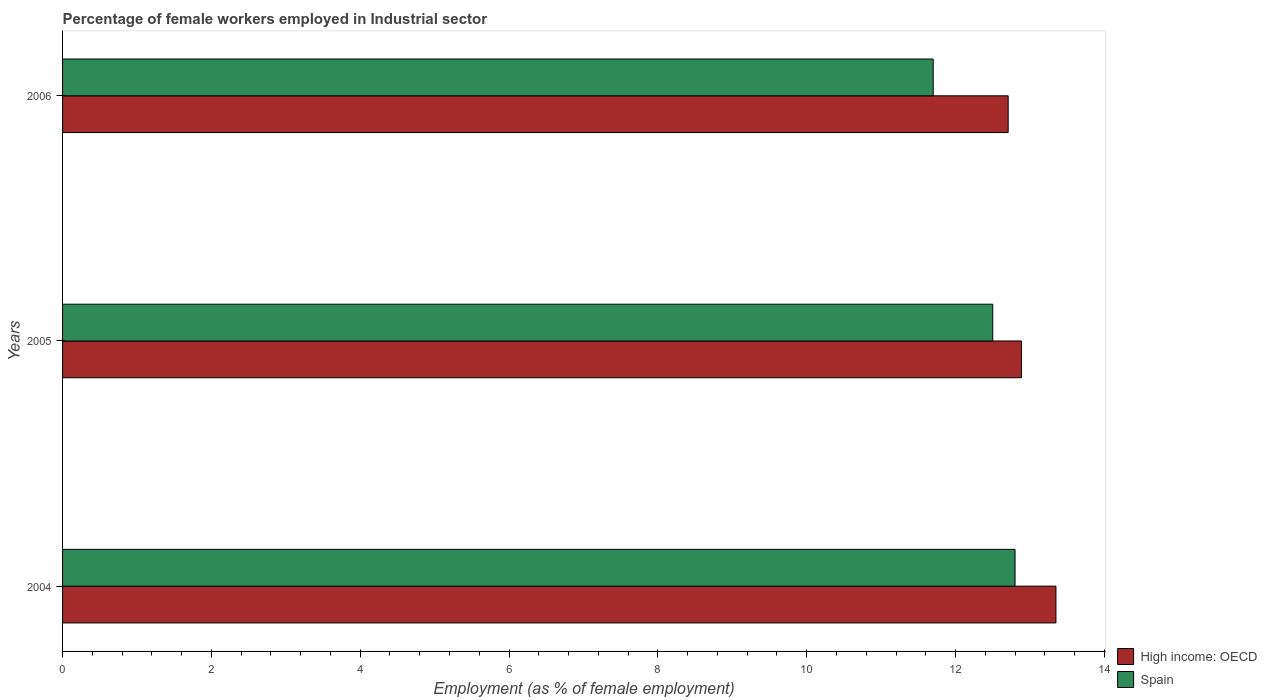How many different coloured bars are there?
Your answer should be compact. 2. How many groups of bars are there?
Provide a succinct answer. 3. How many bars are there on the 2nd tick from the top?
Offer a very short reply. 2. What is the label of the 1st group of bars from the top?
Keep it short and to the point. 2006. In how many cases, is the number of bars for a given year not equal to the number of legend labels?
Give a very brief answer. 0. What is the percentage of females employed in Industrial sector in High income: OECD in 2006?
Your response must be concise. 12.71. Across all years, what is the maximum percentage of females employed in Industrial sector in High income: OECD?
Your answer should be very brief. 13.35. Across all years, what is the minimum percentage of females employed in Industrial sector in Spain?
Your answer should be very brief. 11.7. In which year was the percentage of females employed in Industrial sector in Spain maximum?
Your answer should be very brief. 2004. What is the total percentage of females employed in Industrial sector in High income: OECD in the graph?
Your answer should be very brief. 38.94. What is the difference between the percentage of females employed in Industrial sector in Spain in 2004 and that in 2005?
Offer a terse response. 0.3. What is the difference between the percentage of females employed in Industrial sector in High income: OECD in 2004 and the percentage of females employed in Industrial sector in Spain in 2006?
Your response must be concise. 1.65. What is the average percentage of females employed in Industrial sector in Spain per year?
Your answer should be compact. 12.33. In the year 2006, what is the difference between the percentage of females employed in Industrial sector in Spain and percentage of females employed in Industrial sector in High income: OECD?
Your answer should be very brief. -1.01. In how many years, is the percentage of females employed in Industrial sector in High income: OECD greater than 8.4 %?
Keep it short and to the point. 3. What is the ratio of the percentage of females employed in Industrial sector in High income: OECD in 2004 to that in 2005?
Ensure brevity in your answer.  1.04. Is the percentage of females employed in Industrial sector in High income: OECD in 2005 less than that in 2006?
Your response must be concise. No. Is the difference between the percentage of females employed in Industrial sector in Spain in 2004 and 2005 greater than the difference between the percentage of females employed in Industrial sector in High income: OECD in 2004 and 2005?
Provide a succinct answer. No. What is the difference between the highest and the second highest percentage of females employed in Industrial sector in Spain?
Ensure brevity in your answer.  0.3. What is the difference between the highest and the lowest percentage of females employed in Industrial sector in Spain?
Ensure brevity in your answer.  1.1. Is the sum of the percentage of females employed in Industrial sector in Spain in 2004 and 2006 greater than the maximum percentage of females employed in Industrial sector in High income: OECD across all years?
Keep it short and to the point. Yes. What does the 2nd bar from the top in 2006 represents?
Your answer should be very brief. High income: OECD. What does the 1st bar from the bottom in 2006 represents?
Make the answer very short. High income: OECD. How many years are there in the graph?
Give a very brief answer. 3. Does the graph contain grids?
Offer a terse response. No. Where does the legend appear in the graph?
Your answer should be compact. Bottom right. How are the legend labels stacked?
Give a very brief answer. Vertical. What is the title of the graph?
Your response must be concise. Percentage of female workers employed in Industrial sector. What is the label or title of the X-axis?
Provide a short and direct response. Employment (as % of female employment). What is the label or title of the Y-axis?
Offer a terse response. Years. What is the Employment (as % of female employment) in High income: OECD in 2004?
Keep it short and to the point. 13.35. What is the Employment (as % of female employment) of Spain in 2004?
Provide a succinct answer. 12.8. What is the Employment (as % of female employment) of High income: OECD in 2005?
Your response must be concise. 12.89. What is the Employment (as % of female employment) in High income: OECD in 2006?
Make the answer very short. 12.71. What is the Employment (as % of female employment) in Spain in 2006?
Give a very brief answer. 11.7. Across all years, what is the maximum Employment (as % of female employment) of High income: OECD?
Provide a succinct answer. 13.35. Across all years, what is the maximum Employment (as % of female employment) in Spain?
Offer a very short reply. 12.8. Across all years, what is the minimum Employment (as % of female employment) of High income: OECD?
Give a very brief answer. 12.71. Across all years, what is the minimum Employment (as % of female employment) in Spain?
Provide a succinct answer. 11.7. What is the total Employment (as % of female employment) in High income: OECD in the graph?
Provide a short and direct response. 38.94. What is the difference between the Employment (as % of female employment) of High income: OECD in 2004 and that in 2005?
Offer a terse response. 0.46. What is the difference between the Employment (as % of female employment) of Spain in 2004 and that in 2005?
Keep it short and to the point. 0.3. What is the difference between the Employment (as % of female employment) of High income: OECD in 2004 and that in 2006?
Make the answer very short. 0.64. What is the difference between the Employment (as % of female employment) of Spain in 2004 and that in 2006?
Your answer should be compact. 1.1. What is the difference between the Employment (as % of female employment) in High income: OECD in 2005 and that in 2006?
Offer a very short reply. 0.18. What is the difference between the Employment (as % of female employment) in Spain in 2005 and that in 2006?
Your response must be concise. 0.8. What is the difference between the Employment (as % of female employment) in High income: OECD in 2004 and the Employment (as % of female employment) in Spain in 2005?
Offer a terse response. 0.85. What is the difference between the Employment (as % of female employment) in High income: OECD in 2004 and the Employment (as % of female employment) in Spain in 2006?
Your response must be concise. 1.65. What is the difference between the Employment (as % of female employment) in High income: OECD in 2005 and the Employment (as % of female employment) in Spain in 2006?
Keep it short and to the point. 1.19. What is the average Employment (as % of female employment) in High income: OECD per year?
Give a very brief answer. 12.98. What is the average Employment (as % of female employment) in Spain per year?
Your response must be concise. 12.33. In the year 2004, what is the difference between the Employment (as % of female employment) of High income: OECD and Employment (as % of female employment) of Spain?
Offer a very short reply. 0.55. In the year 2005, what is the difference between the Employment (as % of female employment) of High income: OECD and Employment (as % of female employment) of Spain?
Your answer should be very brief. 0.39. In the year 2006, what is the difference between the Employment (as % of female employment) of High income: OECD and Employment (as % of female employment) of Spain?
Provide a short and direct response. 1.01. What is the ratio of the Employment (as % of female employment) in High income: OECD in 2004 to that in 2005?
Give a very brief answer. 1.04. What is the ratio of the Employment (as % of female employment) of High income: OECD in 2004 to that in 2006?
Give a very brief answer. 1.05. What is the ratio of the Employment (as % of female employment) in Spain in 2004 to that in 2006?
Provide a short and direct response. 1.09. What is the ratio of the Employment (as % of female employment) of High income: OECD in 2005 to that in 2006?
Provide a short and direct response. 1.01. What is the ratio of the Employment (as % of female employment) in Spain in 2005 to that in 2006?
Provide a succinct answer. 1.07. What is the difference between the highest and the second highest Employment (as % of female employment) in High income: OECD?
Keep it short and to the point. 0.46. What is the difference between the highest and the second highest Employment (as % of female employment) of Spain?
Provide a short and direct response. 0.3. What is the difference between the highest and the lowest Employment (as % of female employment) in High income: OECD?
Offer a terse response. 0.64. What is the difference between the highest and the lowest Employment (as % of female employment) in Spain?
Your response must be concise. 1.1. 